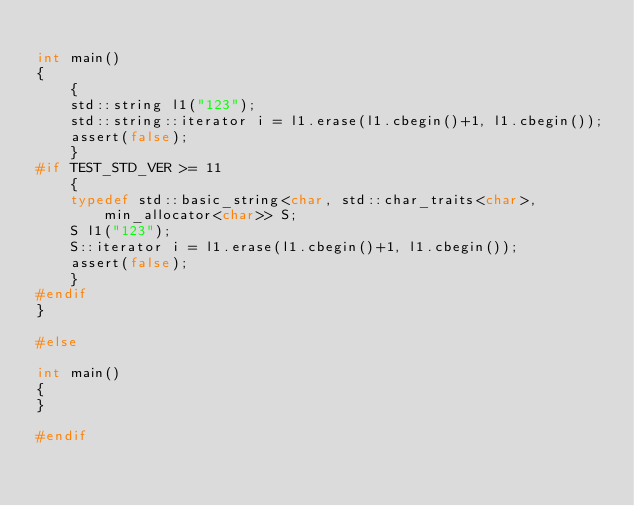<code> <loc_0><loc_0><loc_500><loc_500><_C++_>
int main()
{
    {
    std::string l1("123");
    std::string::iterator i = l1.erase(l1.cbegin()+1, l1.cbegin());
    assert(false);
    }
#if TEST_STD_VER >= 11
    {
    typedef std::basic_string<char, std::char_traits<char>, min_allocator<char>> S;
    S l1("123");
    S::iterator i = l1.erase(l1.cbegin()+1, l1.cbegin());
    assert(false);
    }
#endif
}

#else

int main()
{
}

#endif
</code> 